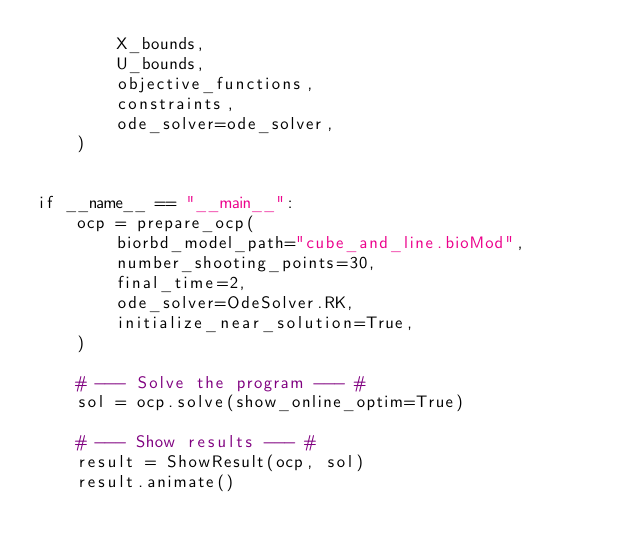Convert code to text. <code><loc_0><loc_0><loc_500><loc_500><_Python_>        X_bounds,
        U_bounds,
        objective_functions,
        constraints,
        ode_solver=ode_solver,
    )


if __name__ == "__main__":
    ocp = prepare_ocp(
        biorbd_model_path="cube_and_line.bioMod",
        number_shooting_points=30,
        final_time=2,
        ode_solver=OdeSolver.RK,
        initialize_near_solution=True,
    )

    # --- Solve the program --- #
    sol = ocp.solve(show_online_optim=True)

    # --- Show results --- #
    result = ShowResult(ocp, sol)
    result.animate()
</code> 